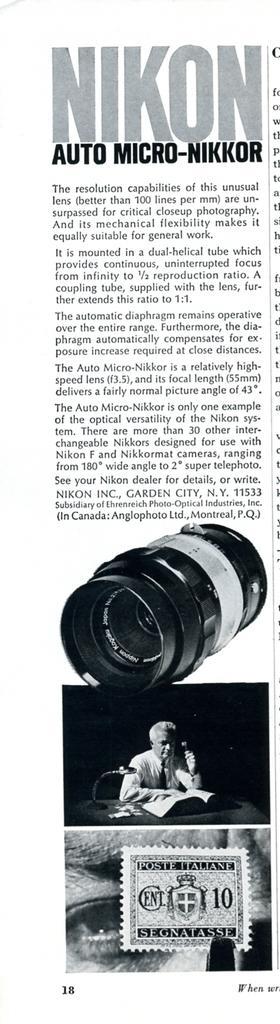How would you summarize this image in a sentence or two? In the picture I can see photos of people and some other objects. I can also see something written on the image. This photos are black and white in color. 